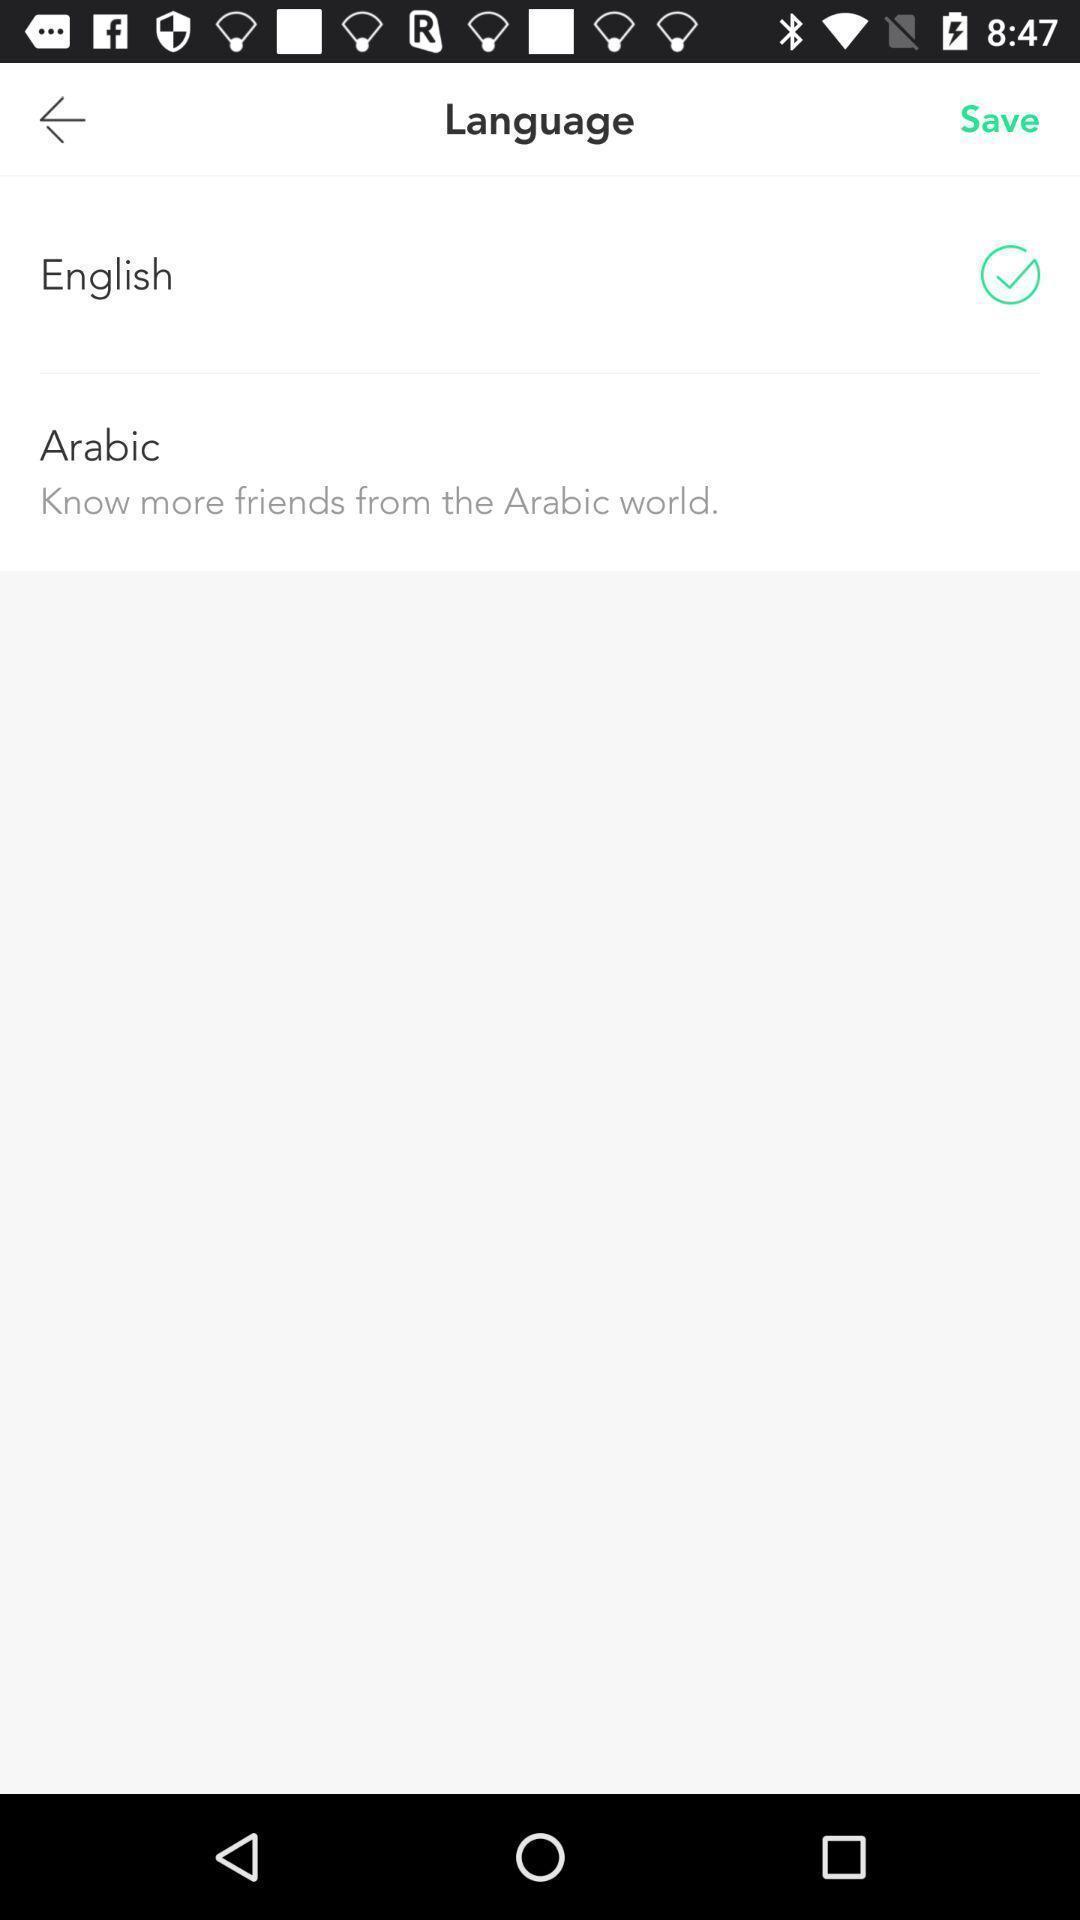What details can you identify in this image? Screen displaying the language settings page. 